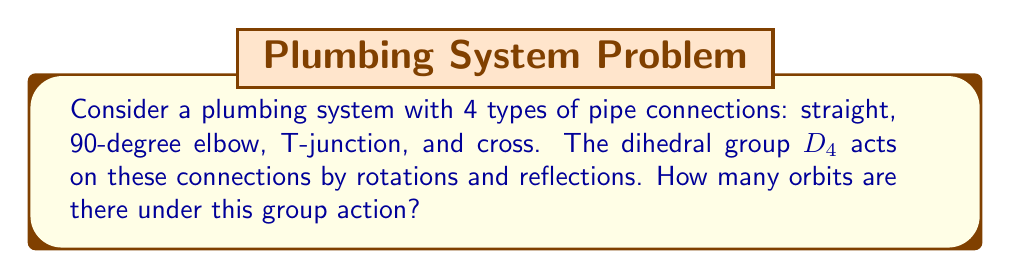Show me your answer to this math problem. Let's approach this step-by-step using Burnside's lemma:

1) First, we need to identify the elements of $D_4$:
   - Identity (e)
   - Rotations by 90°, 180°, and 270° (r, r², r³)
   - Reflections across 4 axes (s, sr, sr², sr³)

2) Now, we count the number of fixed points for each group element:

   a) Identity (e): Fixes all 4 connections
      $|Fix(e)| = 4$

   b) 90° rotation (r): Fixes only the cross
      $|Fix(r)| = 1$

   c) 180° rotation (r²): Fixes the cross and straight connection
      $|Fix(r²)| = 2$

   d) 270° rotation (r³): Same as 90° rotation
      $|Fix(r³)| = 1$

   e) Reflections (s, sr, sr², sr³): Each fixes 2 connections
      $|Fix(s)| = |Fix(sr)| = |Fix(sr²)| = |Fix(sr³)| = 2$

3) Apply Burnside's lemma:
   $$\text{Number of orbits} = \frac{1}{|G|} \sum_{g \in G} |Fix(g)|$$
   
   Where $|G|$ is the order of the group (8 for $D_4$)

4) Substituting the values:
   $$\text{Number of orbits} = \frac{1}{8}(4 + 1 + 2 + 1 + 2 + 2 + 2 + 2)$$

5) Simplify:
   $$\text{Number of orbits} = \frac{1}{8}(16) = 2$$

Therefore, there are 2 orbits under this group action.
Answer: 2 orbits 